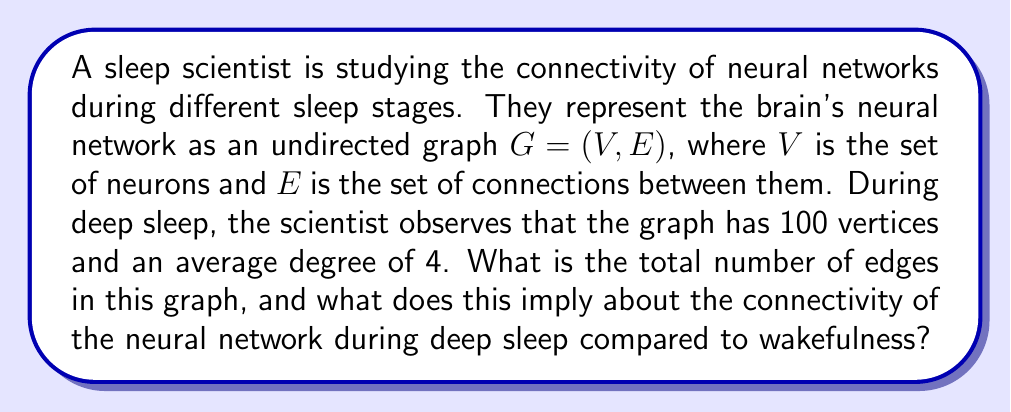Show me your answer to this math problem. To solve this problem, we need to understand the relationship between the number of vertices, edges, and the average degree in an undirected graph.

1. Let's define our variables:
   $|V| = 100$ (number of vertices)
   $|E|$ = number of edges (unknown)
   $\bar{d} = 4$ (average degree)

2. In an undirected graph, the sum of all vertex degrees is equal to twice the number of edges. This is because each edge contributes to the degree of two vertices. We can express this as:

   $$\sum_{v \in V} \deg(v) = 2|E|$$

3. The average degree is defined as the sum of all vertex degrees divided by the number of vertices:

   $$\bar{d} = \frac{\sum_{v \in V} \deg(v)}{|V|}$$

4. Substituting the equation from step 2 into step 3:

   $$\bar{d} = \frac{2|E|}{|V|}$$

5. Now we can solve for $|E|$:

   $$4 = \frac{2|E|}{100}$$
   $$400 = 2|E|$$
   $$|E| = 200$$

6. Therefore, the graph has 200 edges during deep sleep.

7. To interpret this result in the context of neural connectivity:
   - During deep sleep, each neuron is connected to an average of 4 other neurons.
   - This relatively low connectivity suggests a more segregated neural network compared to wakefulness, where connectivity is typically higher.
   - The reduced connectivity during deep sleep may facilitate processes such as memory consolidation and synaptic homeostasis, which are important functions of sleep.
Answer: The graph has 200 edges during deep sleep. This implies a reduced neural network connectivity compared to wakefulness, which may support important sleep functions such as memory consolidation and synaptic homeostasis. 